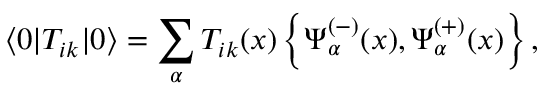<formula> <loc_0><loc_0><loc_500><loc_500>\langle 0 | T _ { i k } | 0 \rangle = \sum _ { \alpha } T _ { i k } ( x ) \left \{ \Psi _ { \alpha } ^ { ( - ) } ( x ) , \Psi _ { \alpha } ^ { ( + ) } ( x ) \right \} ,</formula> 